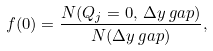Convert formula to latex. <formula><loc_0><loc_0><loc_500><loc_500>f ( 0 ) = \frac { N ( Q _ { j } = 0 , \, \Delta y \, g a p ) } { N ( \Delta y \, g a p ) } ,</formula> 